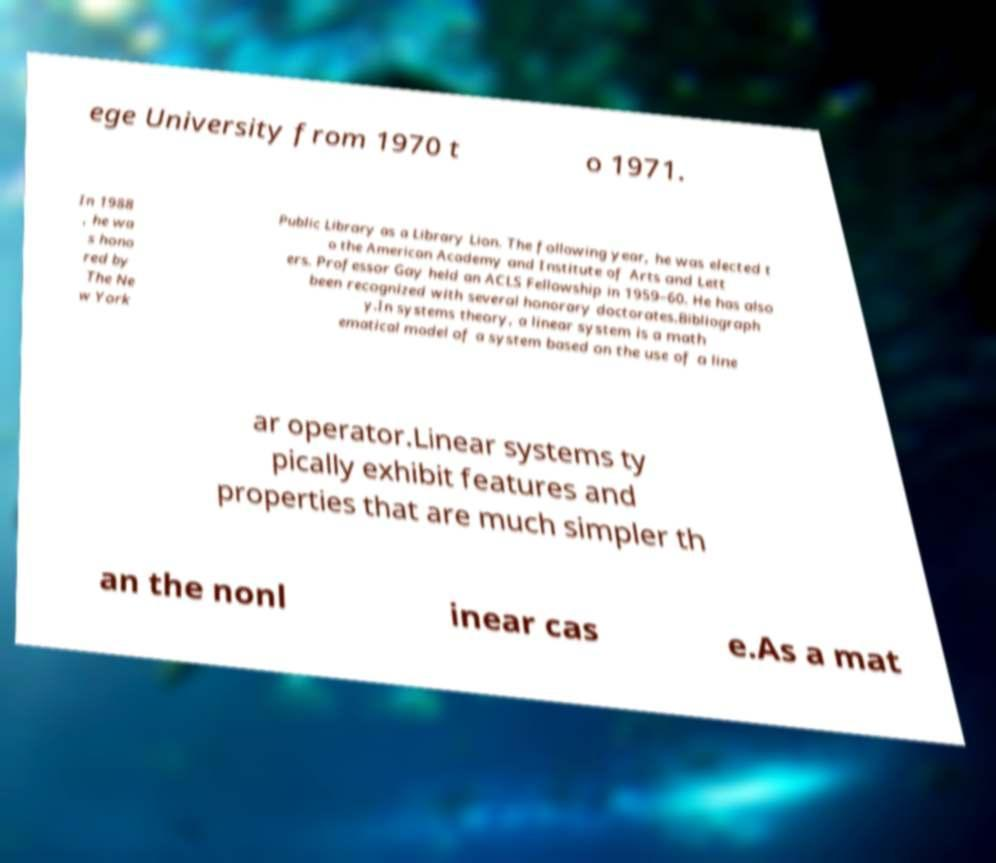I need the written content from this picture converted into text. Can you do that? ege University from 1970 t o 1971. In 1988 , he wa s hono red by The Ne w York Public Library as a Library Lion. The following year, he was elected t o the American Academy and Institute of Arts and Lett ers. Professor Gay held an ACLS Fellowship in 1959–60. He has also been recognized with several honorary doctorates.Bibliograph y.In systems theory, a linear system is a math ematical model of a system based on the use of a line ar operator.Linear systems ty pically exhibit features and properties that are much simpler th an the nonl inear cas e.As a mat 